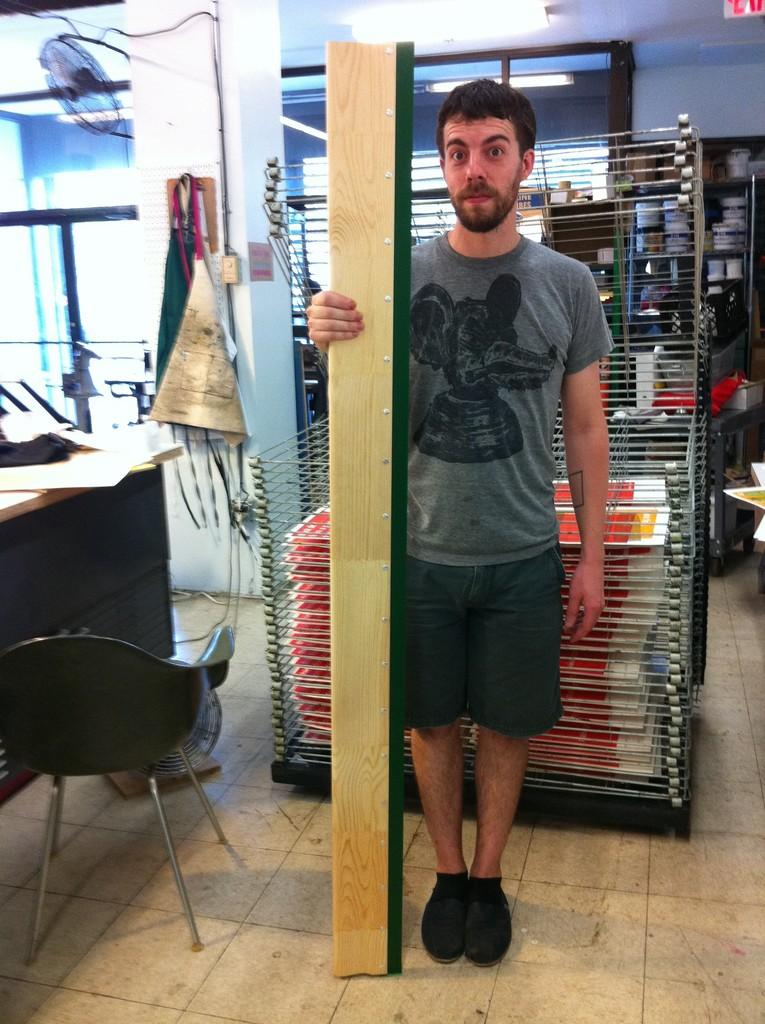What is the main subject of the image? There is a man standing in the image. Where is the man standing? The man is standing on the floor. What other furniture is present in the image? There is a chair, a table, and a rack in the image. What type of trade is the man participating in while standing in the image? There is no indication of any trade in the image; the man is simply standing. Can you see a monkey on the man's shoulder in the image? No, there is no monkey present in the image. 